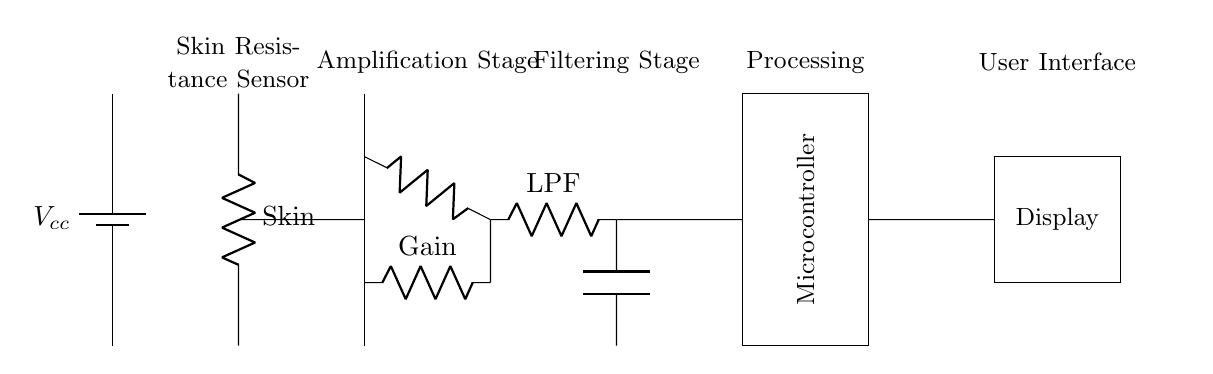What is the main power supply used in the circuit? The circuit uses a battery as the main power supply, indicated by the symbol for a battery at the top left of the diagram.
Answer: Battery What type of sensor is used in this circuit? The circuit includes a skin resistance sensor, which is shown at the top left next to the battery symbol.
Answer: Skin resistance sensor What component is responsible for amplifying the signal? The op amplifier in the middle of the circuit is responsible for amplifying the signal, as indicated by its symbol and label.
Answer: Op amplifier Which component filters out high-frequency noise in the circuit? The low-pass filter is used to filter out high-frequency noise, as indicated by its label and position in the signal path.
Answer: Low-pass filter How many main stages are present in this biofeedback circuit? There are four main stages present: sensing, amplification, filtering, and processing, which are visually represented by different labeled sections within the circuit.
Answer: Four stages What might be the purpose of the microcontroller in this circuit? The microcontroller is used to process the data received from the sensing and filtering stages, as indicated by its label and position between those components and the display.
Answer: Data processing Which component serves as the user interface? The display component serves as the user interface, as indicated by its position and label, making it clear how the user will interact with the circuit's output.
Answer: Display 